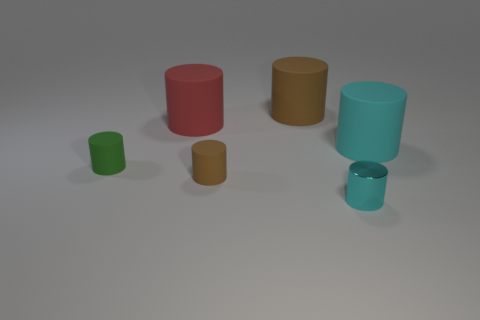There is another cylinder that is the same color as the tiny metal cylinder; what material is it?
Make the answer very short. Rubber. What material is the brown cylinder in front of the cyan cylinder behind the tiny brown cylinder?
Your answer should be very brief. Rubber. There is a large object that is on the left side of the cyan rubber thing and in front of the large brown cylinder; what is it made of?
Your answer should be very brief. Rubber. Is there a big purple thing of the same shape as the green object?
Ensure brevity in your answer.  No. Is there a cyan shiny object behind the tiny rubber object behind the tiny brown rubber thing?
Give a very brief answer. No. What number of red cylinders have the same material as the red object?
Offer a terse response. 0. Are there any cyan rubber objects?
Give a very brief answer. Yes. What number of small metallic cylinders have the same color as the tiny metallic object?
Make the answer very short. 0. Are the large brown thing and the big cylinder that is in front of the large red matte cylinder made of the same material?
Give a very brief answer. Yes. Is the number of brown objects right of the tiny metallic cylinder greater than the number of small shiny objects?
Your answer should be compact. No. 